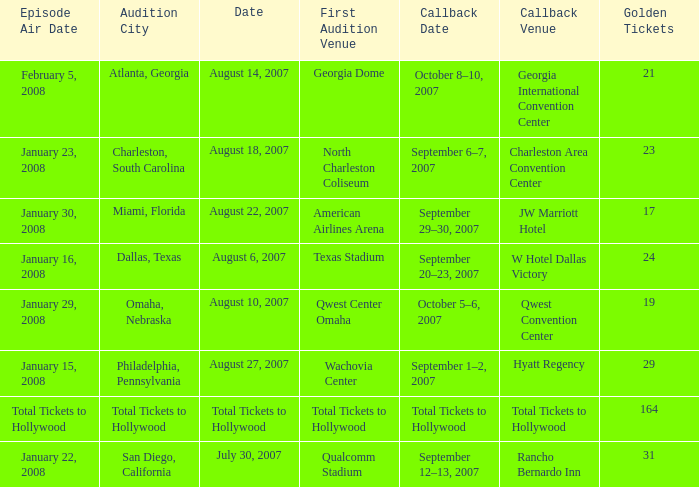What day has a callback Venue of total tickets to hollywood? Question Total Tickets to Hollywood. 